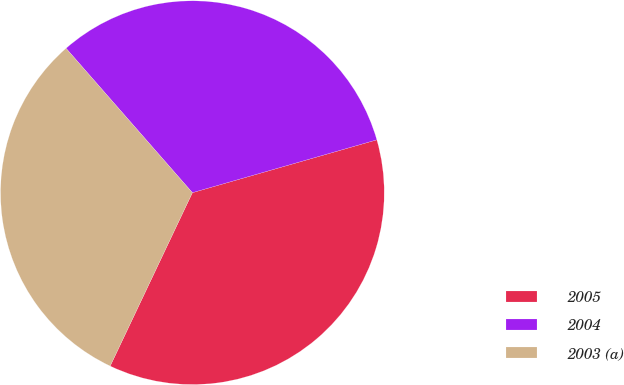Convert chart. <chart><loc_0><loc_0><loc_500><loc_500><pie_chart><fcel>2005<fcel>2004<fcel>2003 (a)<nl><fcel>36.49%<fcel>32.0%<fcel>31.51%<nl></chart> 